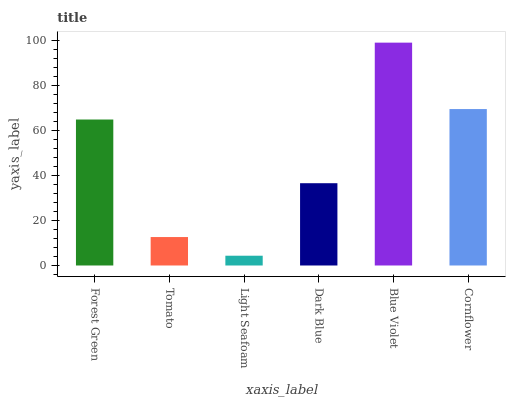Is Light Seafoam the minimum?
Answer yes or no. Yes. Is Blue Violet the maximum?
Answer yes or no. Yes. Is Tomato the minimum?
Answer yes or no. No. Is Tomato the maximum?
Answer yes or no. No. Is Forest Green greater than Tomato?
Answer yes or no. Yes. Is Tomato less than Forest Green?
Answer yes or no. Yes. Is Tomato greater than Forest Green?
Answer yes or no. No. Is Forest Green less than Tomato?
Answer yes or no. No. Is Forest Green the high median?
Answer yes or no. Yes. Is Dark Blue the low median?
Answer yes or no. Yes. Is Light Seafoam the high median?
Answer yes or no. No. Is Cornflower the low median?
Answer yes or no. No. 